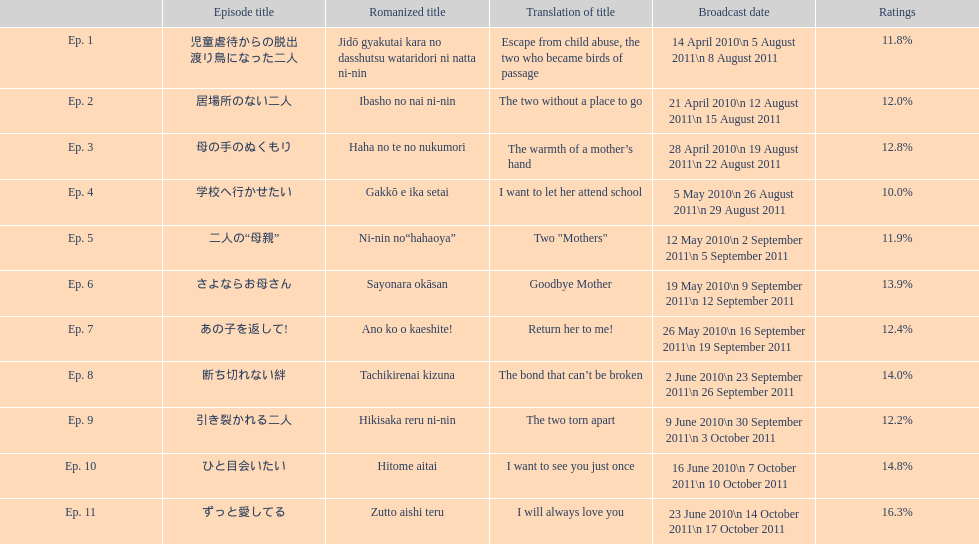What was the proportionate sum of ratings for episode 8? 14.0%. 